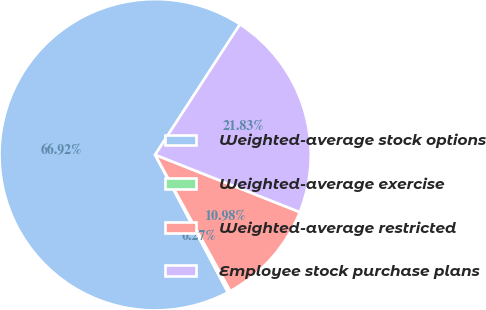Convert chart to OTSL. <chart><loc_0><loc_0><loc_500><loc_500><pie_chart><fcel>Weighted-average stock options<fcel>Weighted-average exercise<fcel>Weighted-average restricted<fcel>Employee stock purchase plans<nl><fcel>66.92%<fcel>0.27%<fcel>10.98%<fcel>21.83%<nl></chart> 